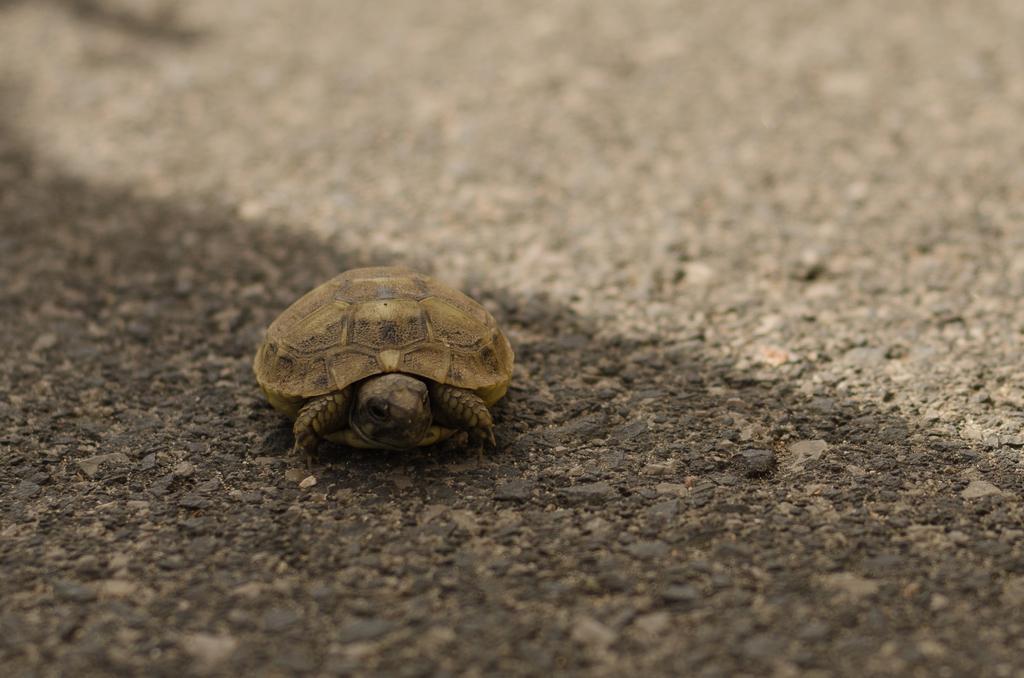Can you describe this image briefly? In the image there is a small turtle on the ground. 